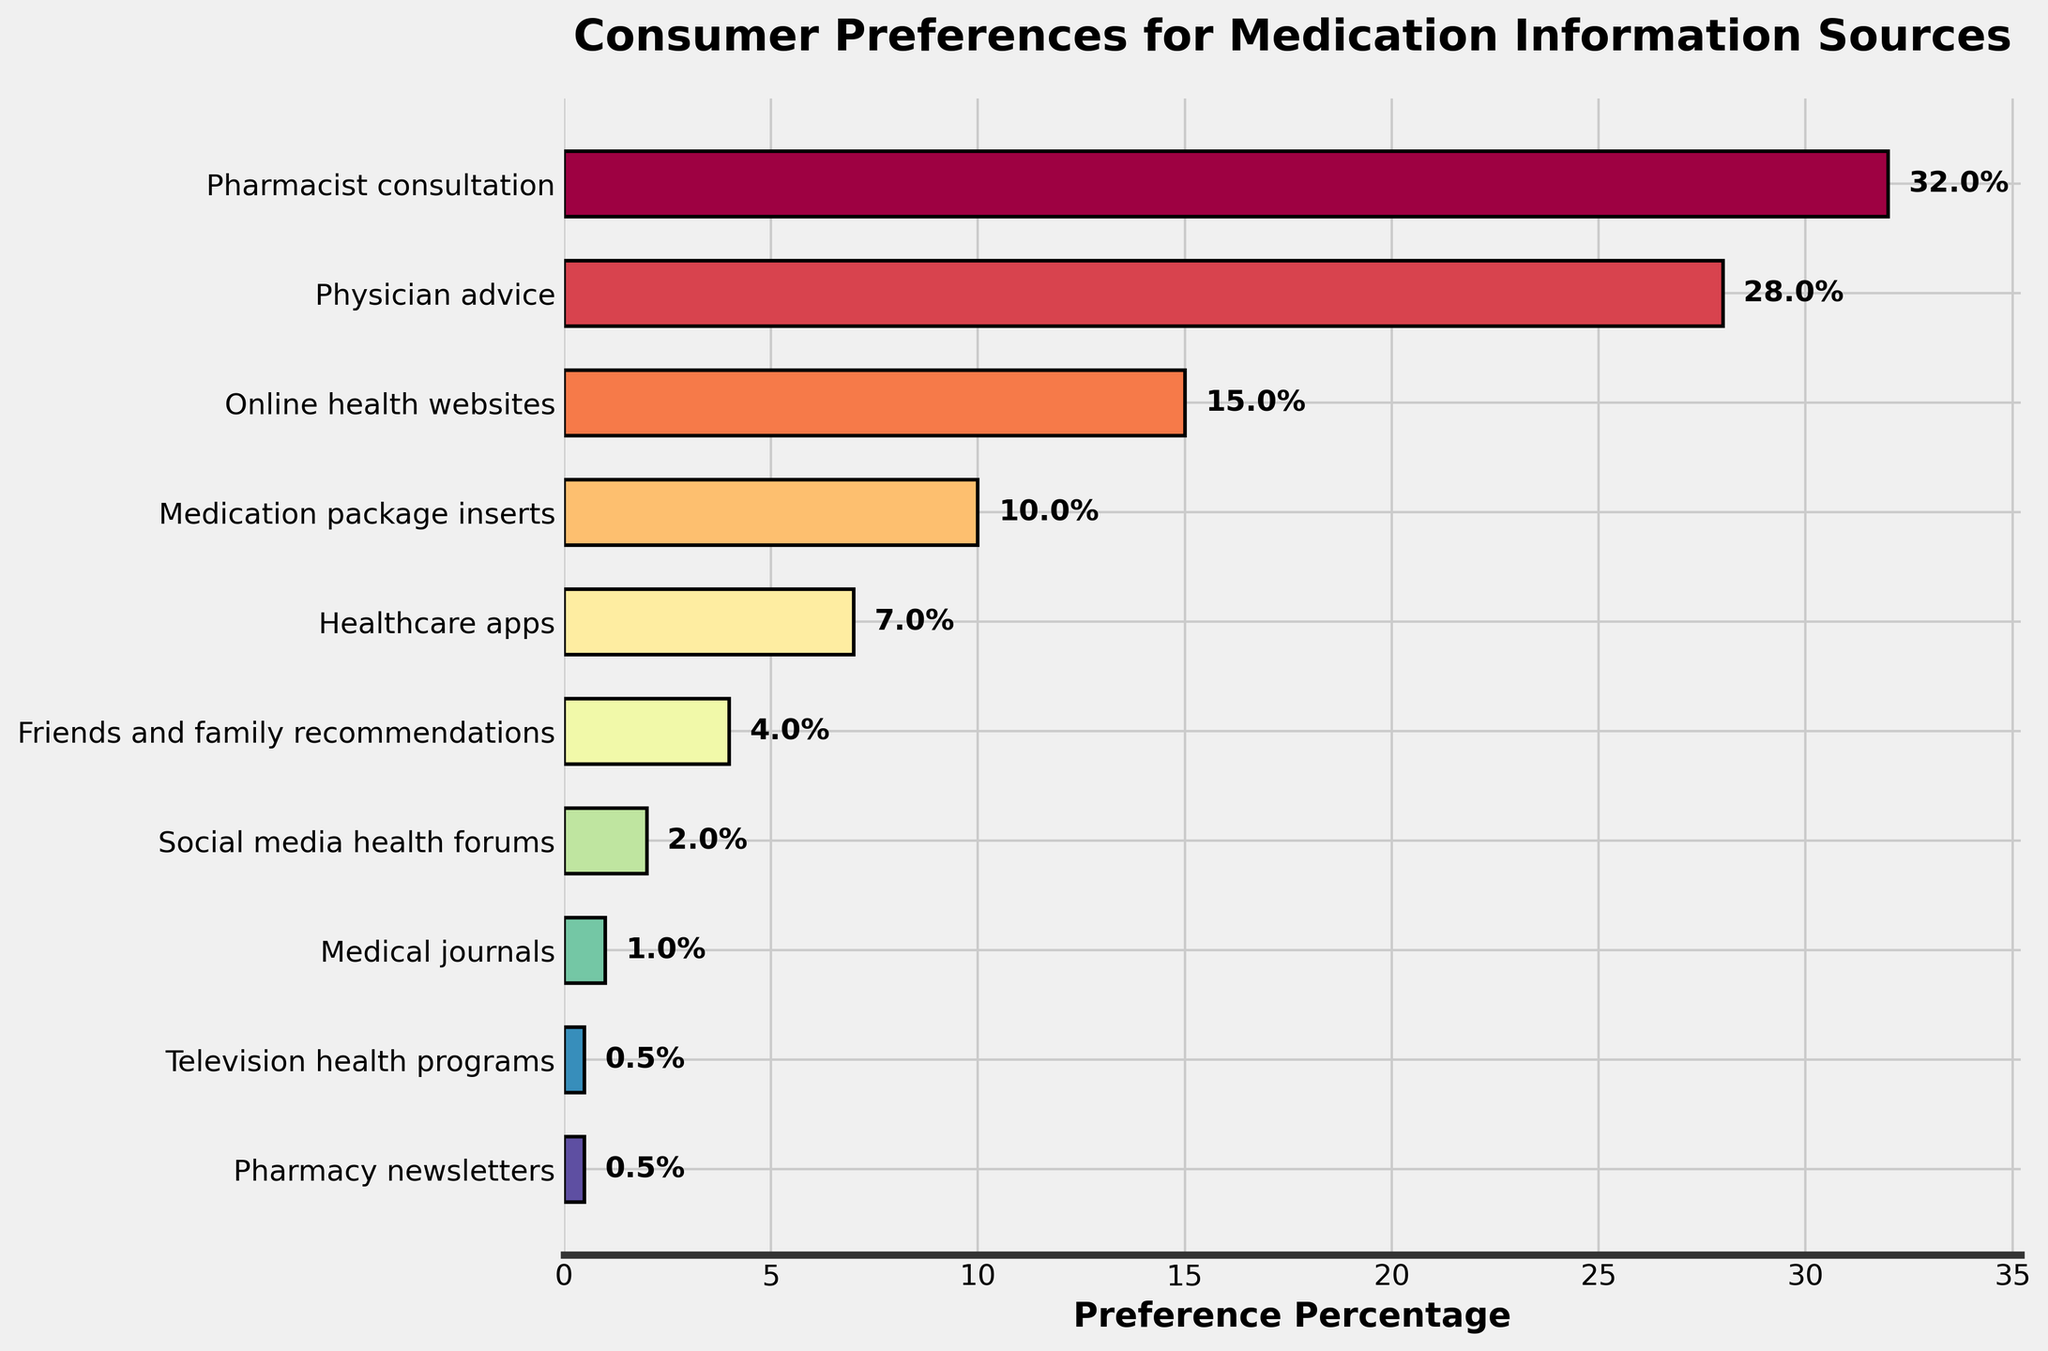Which source has the highest consumer preference? The bar representing 'Pharmacist consultation' is the longest, and the percentage next to it reads 32%.
Answer: Pharmacist consultation Which source has the lowest preference percentage? 'Television health programs' and 'Pharmacy newsletters' have the shortest bars, each at 0.5%.
Answer: Television health programs, Pharmacy newsletters What is the combined preference percentage for 'Physician advice' and 'Friends and family recommendations'? 'Physician advice' has 28%, and 'Friends and family recommendations' has 4%. Adding 28% + 4% = 32%.
Answer: 32% How much more preferred is 'Online health websites' compared to 'Friends and family recommendations'? 'Online health websites' is at 15%, and 'Friends and family recommendations' is at 4%. The difference is 15% - 4% = 11%.
Answer: 11% What is the average preference percentage of the top three sources? The top three sources are 'Pharmacist consultation' (32%), 'Physician advice' (28%), and 'Online health websites' (15%). The average is (32 + 28 + 15) / 3 = 25%.
Answer: 25% Which source, 'Social media health forums' or 'Medical journals', has a higher preference percentage? 'Social media health forums' has 2%, and 'Medical journals' has 1%. 2% is greater than 1%.
Answer: Social media health forums If 'Pharmacist consultation' dropped by 10 percentage points, would it still have the highest preference? Dropping 'Pharmacist consultation' by 10 points gives 32% - 10% = 22%. 'Physician advice' is 28%, which would now be higher than 22%.
Answer: No What is the total preference percentage of all sources that have more than 10% but less than 30% preference? The sources are 'Physician advice' (28%) and 'Online health websites' (15%). The sum is 28% + 15% = 43%.
Answer: 43% What is the percentage difference between 'Healthcare apps' and 'Medication package inserts'? 'Healthcare apps' is at 7%, and 'Medication package inserts' is at 10%. The difference is 10% - 7% = 3%.
Answer: 3% Which category, 'Friends and family recommendations' or 'Online health websites', is less preferred and by how much? 'Friends and family recommendations' is 4%, and 'Online health websites' is 15%. The difference is 15% - 4% = 11%.
Answer: Friends and family recommendations, 11% 